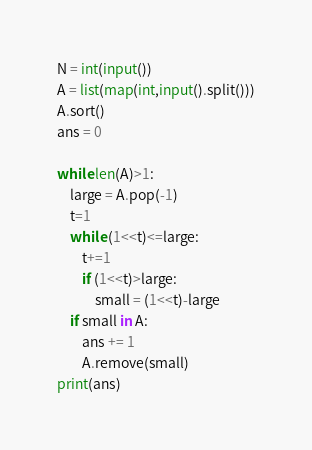Convert code to text. <code><loc_0><loc_0><loc_500><loc_500><_Python_>N = int(input())
A = list(map(int,input().split()))
A.sort()
ans = 0

while len(A)>1:
    large = A.pop(-1)
    t=1
    while (1<<t)<=large:
        t+=1
        if (1<<t)>large:
            small = (1<<t)-large
    if small in A:
        ans += 1
        A.remove(small)
print(ans)
</code> 